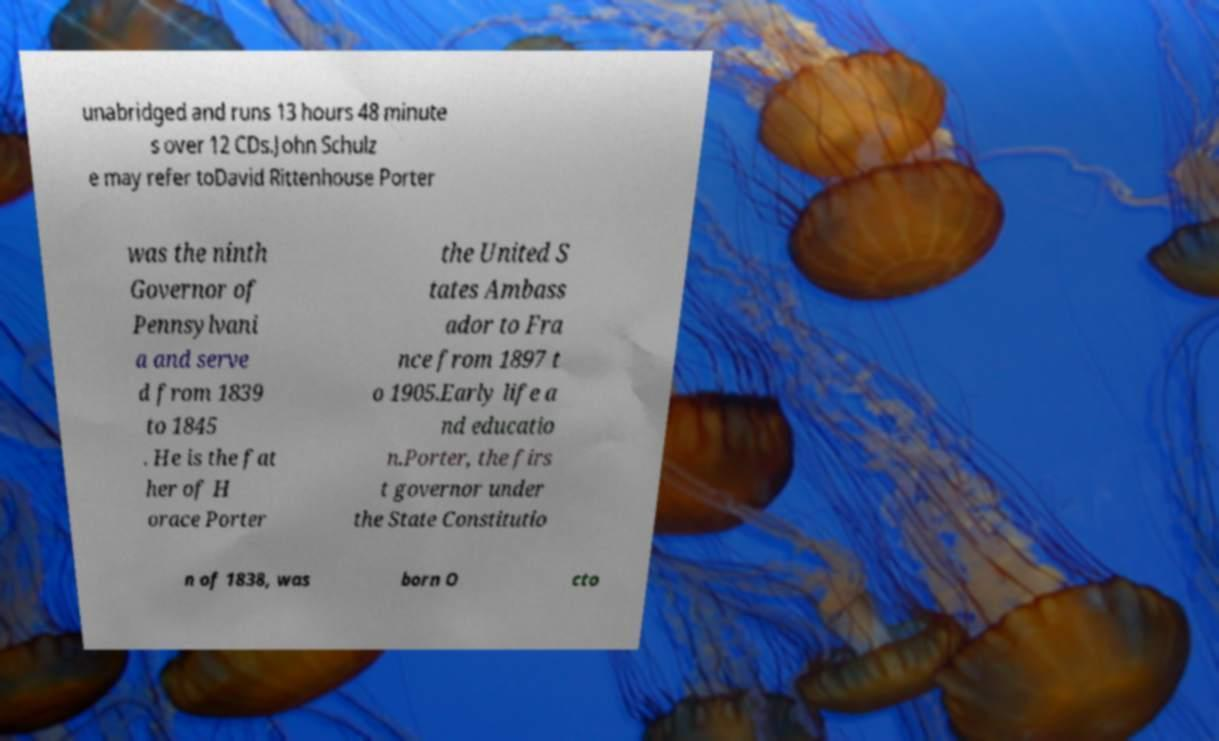Please read and relay the text visible in this image. What does it say? unabridged and runs 13 hours 48 minute s over 12 CDs.John Schulz e may refer toDavid Rittenhouse Porter was the ninth Governor of Pennsylvani a and serve d from 1839 to 1845 . He is the fat her of H orace Porter the United S tates Ambass ador to Fra nce from 1897 t o 1905.Early life a nd educatio n.Porter, the firs t governor under the State Constitutio n of 1838, was born O cto 